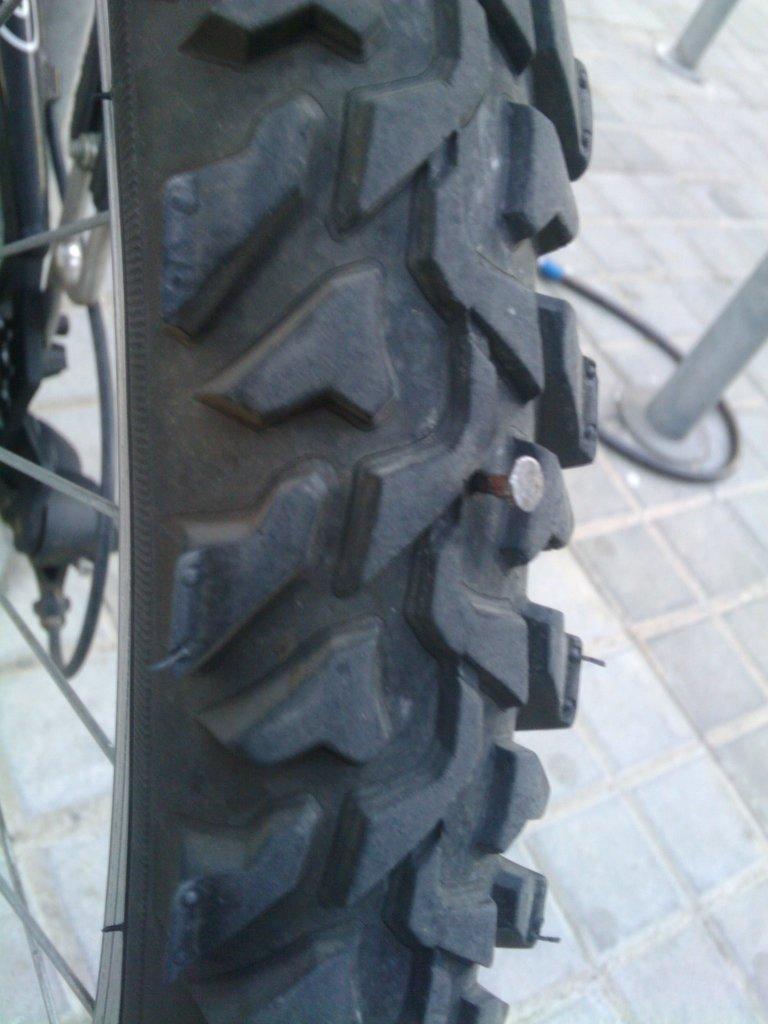In one or two sentences, can you explain what this image depicts? In the foreground of this picture, there is a nail to the Tyre of a bicycle. In the background, there is a pipe and two poles on the floor. 